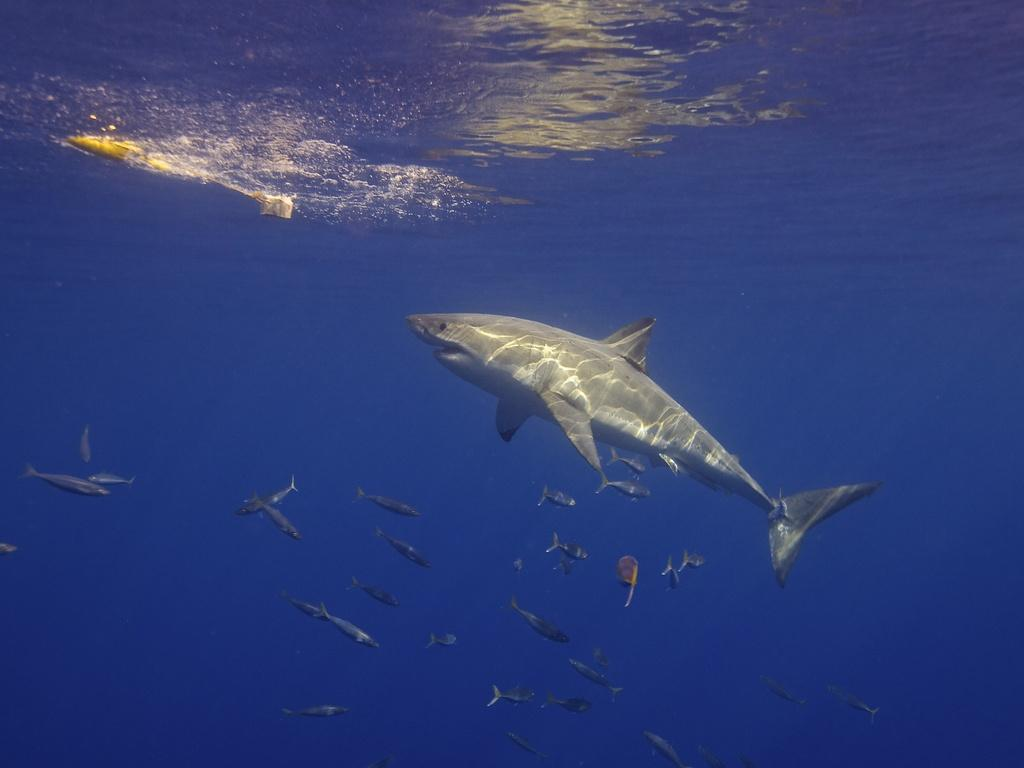What type of animal is in the image? There is a shark in the image. Are there any other animals in the image besides the shark? Yes, there are fishes in the image. Where are the shark and fishes located? The shark and fishes are in the water. What type of lamp is hanging above the shark in the image? There is no lamp present in the image; it features a shark and fishes in the water. 